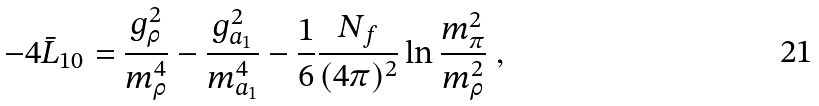<formula> <loc_0><loc_0><loc_500><loc_500>- 4 \bar { L } _ { 1 0 } = \frac { g _ { \rho } ^ { 2 } } { m _ { \rho } ^ { 4 } } - \frac { g _ { a _ { 1 } } ^ { 2 } } { m _ { a _ { 1 } } ^ { 4 } } - \frac { 1 } { 6 } \frac { N _ { f } } { ( 4 \pi ) ^ { 2 } } \ln \frac { m _ { \pi } ^ { 2 } } { m _ { \rho } ^ { 2 } } \ ,</formula> 